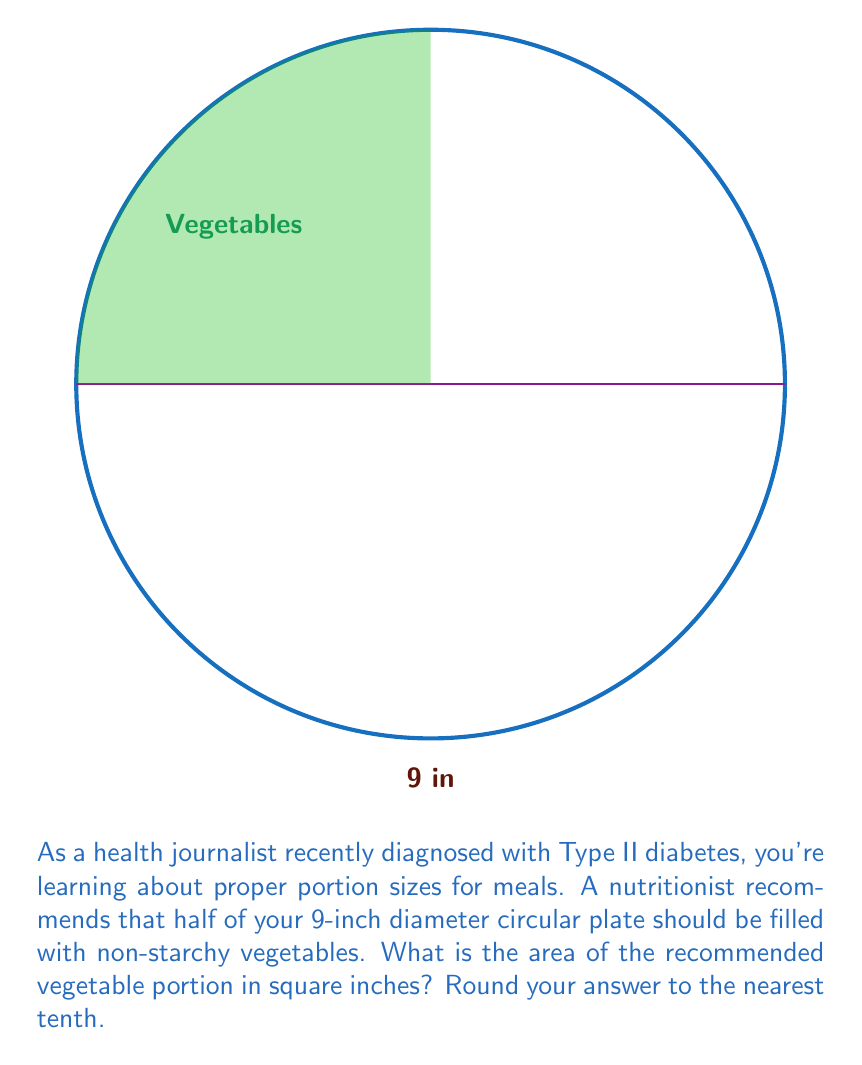Give your solution to this math problem. Let's approach this step-by-step:

1) The plate is circular with a diameter of 9 inches. We need to find the radius:
   $r = \frac{diameter}{2} = \frac{9}{2} = 4.5$ inches

2) The total area of the circular plate is:
   $A_{total} = \pi r^2 = \pi (4.5)^2 = 20.25\pi$ square inches

3) The recommended vegetable portion is half of the plate. So its area will be half of the total area:
   $A_{vegetables} = \frac{1}{2} \times 20.25\pi = 10.125\pi$ square inches

4) Now, let's calculate this:
   $A_{vegetables} = 10.125 \times 3.14159... \approx 31.8$ square inches

5) Rounding to the nearest tenth:
   $A_{vegetables} \approx 31.8$ square inches

This portion size allows for a substantial amount of non-starchy vegetables, which is beneficial for managing blood sugar levels in Type II diabetes.
Answer: 31.8 square inches 